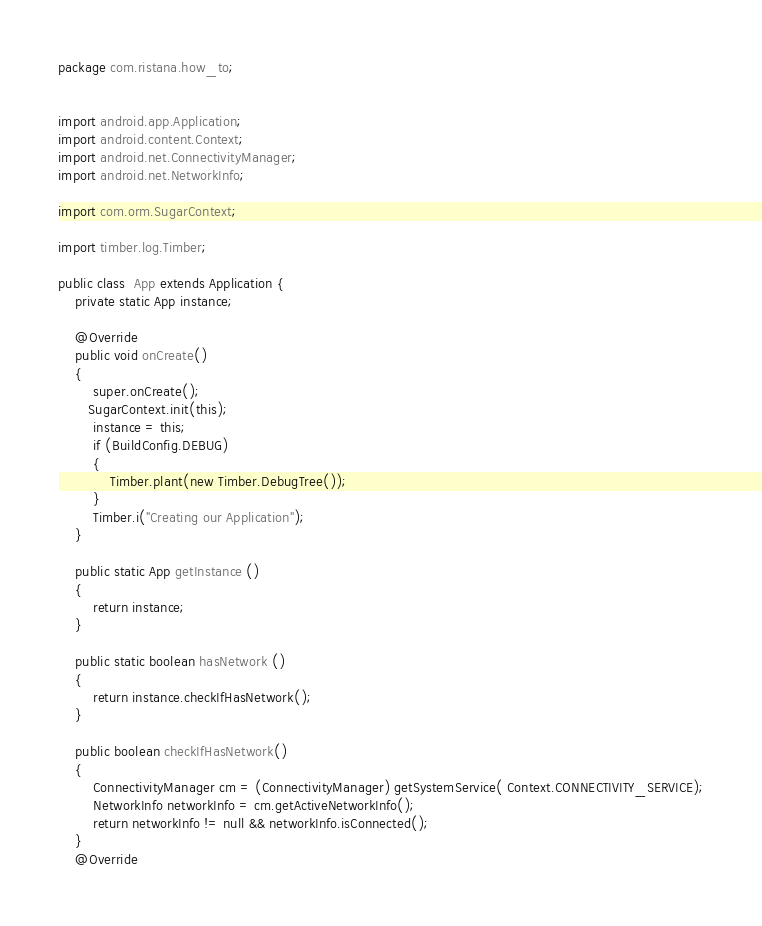Convert code to text. <code><loc_0><loc_0><loc_500><loc_500><_Java_>package com.ristana.how_to;


import android.app.Application;
import android.content.Context;
import android.net.ConnectivityManager;
import android.net.NetworkInfo;

import com.orm.SugarContext;

import timber.log.Timber;

public class  App extends Application {
    private static App instance;

    @Override
    public void onCreate()
    {
        super.onCreate();
       SugarContext.init(this);
        instance = this;
        if (BuildConfig.DEBUG)
        {
            Timber.plant(new Timber.DebugTree());
        }
        Timber.i("Creating our Application");
    }

    public static App getInstance ()
    {
        return instance;
    }

    public static boolean hasNetwork ()
    {
        return instance.checkIfHasNetwork();
    }

    public boolean checkIfHasNetwork()
    {
        ConnectivityManager cm = (ConnectivityManager) getSystemService( Context.CONNECTIVITY_SERVICE);
        NetworkInfo networkInfo = cm.getActiveNetworkInfo();
        return networkInfo != null && networkInfo.isConnected();
    }
    @Override</code> 